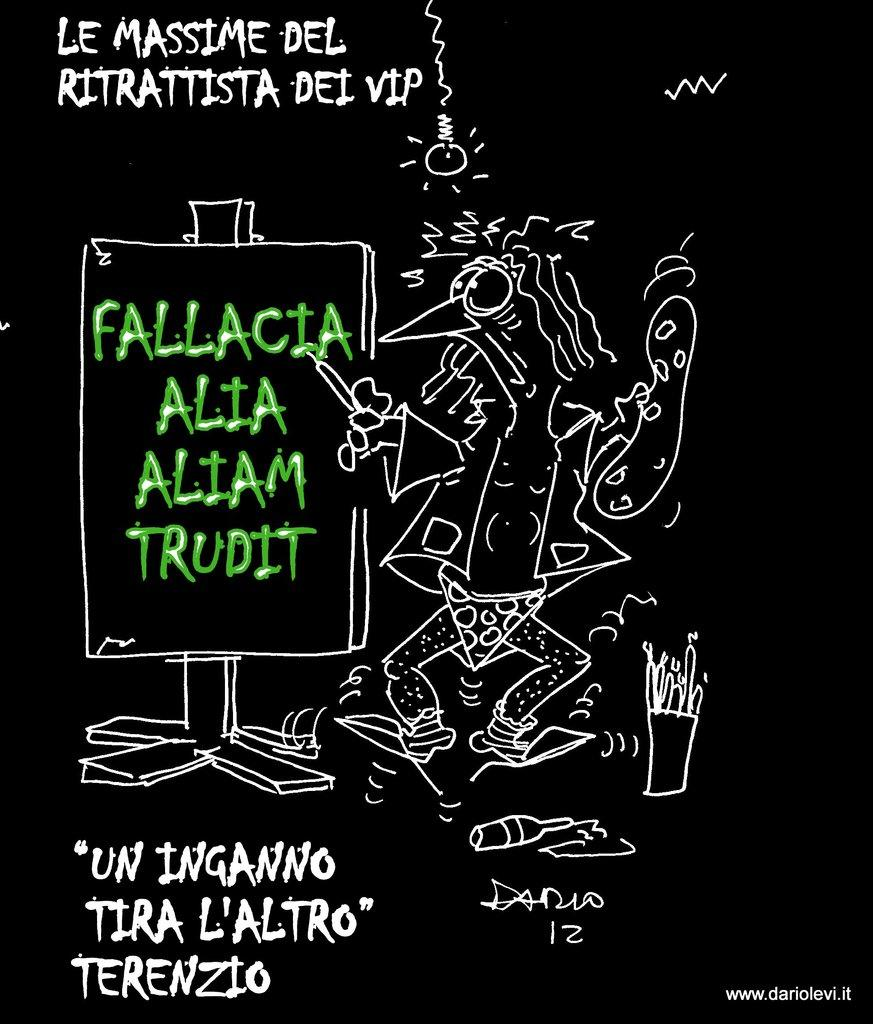Provide a one-sentence caption for the provided image. A black poster with art in white by Dario. 